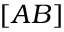<formula> <loc_0><loc_0><loc_500><loc_500>[ A B ]</formula> 